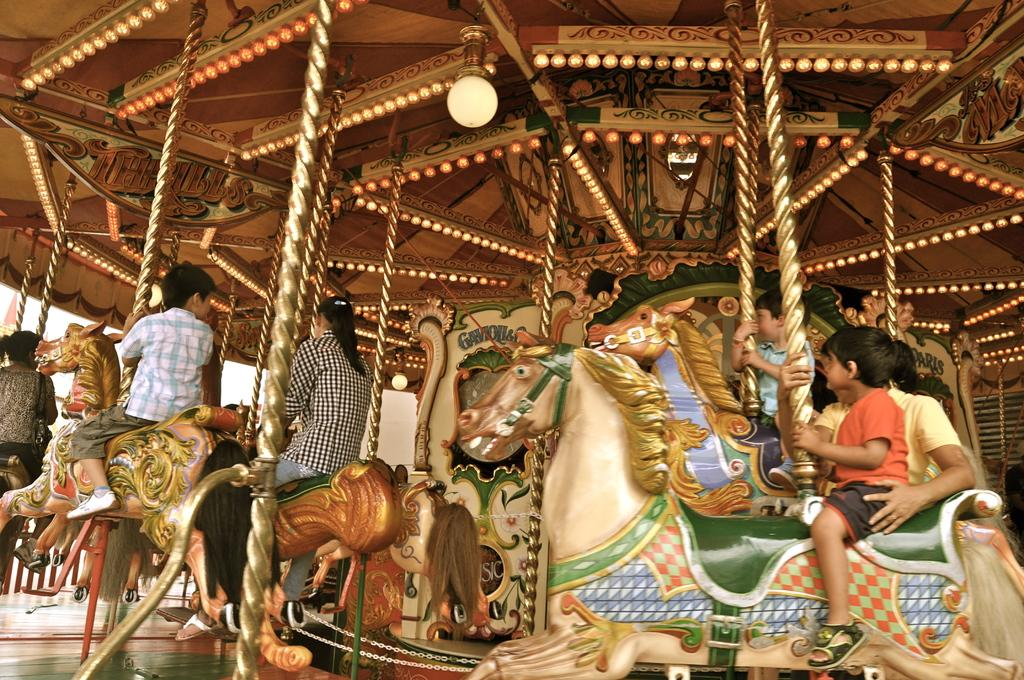What type of ride is featured in the image? There is an amusement ride in the image. What can be seen on the ride? There are toy horses on the ride. Are there any people interacting with the ride? Yes, there are people riding the toy horses. What can be seen on the top of the ride? There is a light on the roof of the ride. What is visible in the background of the image? There are objects visible in the background of the image. Where is the library located in the image? There is no library present in the image. Is anyone wearing a mask while riding the toy horses? There is no mention of masks or people wearing masks in the image. 